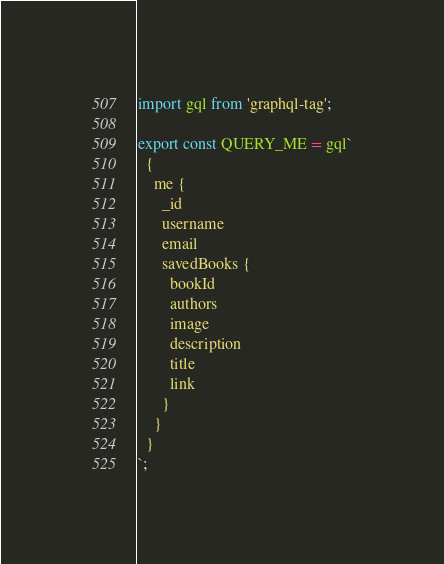<code> <loc_0><loc_0><loc_500><loc_500><_JavaScript_>import gql from 'graphql-tag';

export const QUERY_ME = gql`
  {
    me {
      _id
      username
      email
      savedBooks {
        bookId
        authors
        image
        description
        title
        link
      }
    }
  }
`;
</code> 